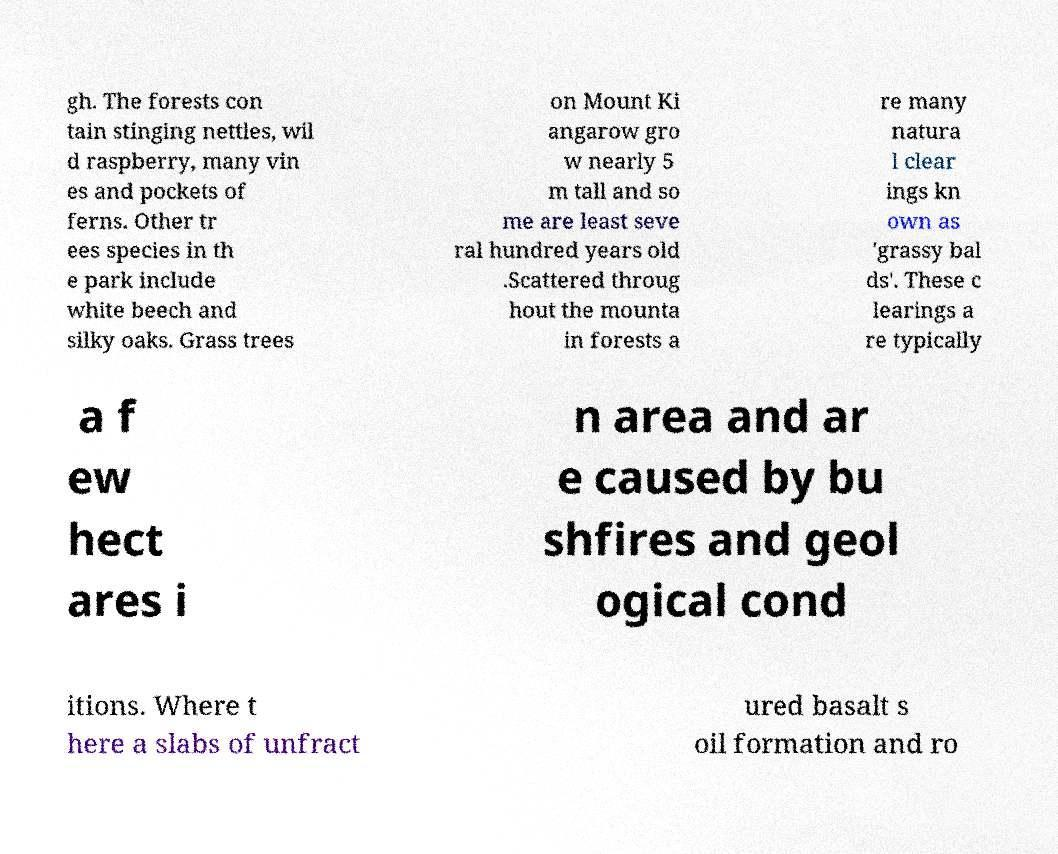Please identify and transcribe the text found in this image. gh. The forests con tain stinging nettles, wil d raspberry, many vin es and pockets of ferns. Other tr ees species in th e park include white beech and silky oaks. Grass trees on Mount Ki angarow gro w nearly 5 m tall and so me are least seve ral hundred years old .Scattered throug hout the mounta in forests a re many natura l clear ings kn own as 'grassy bal ds'. These c learings a re typically a f ew hect ares i n area and ar e caused by bu shfires and geol ogical cond itions. Where t here a slabs of unfract ured basalt s oil formation and ro 